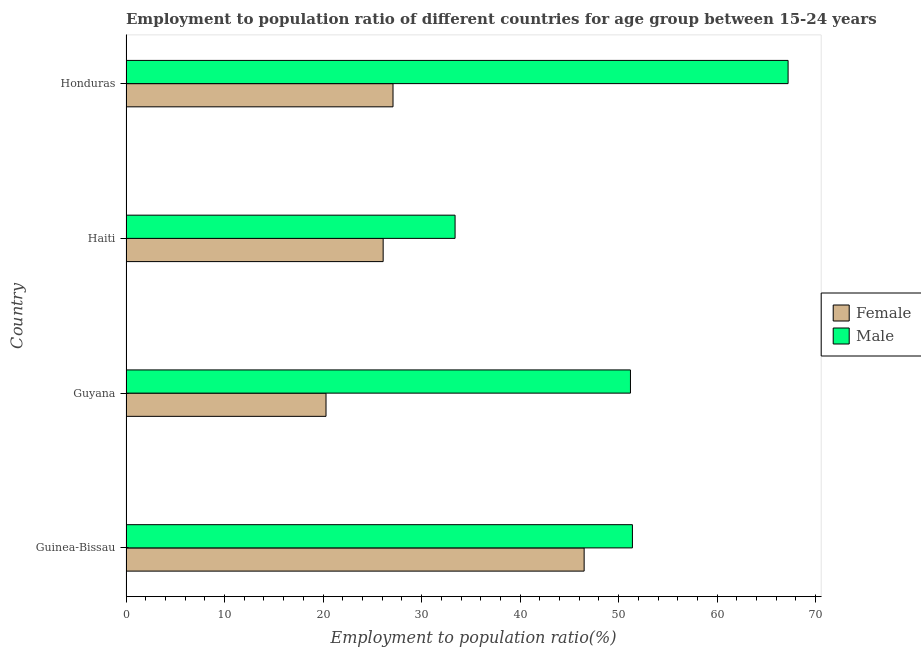Are the number of bars on each tick of the Y-axis equal?
Make the answer very short. Yes. How many bars are there on the 1st tick from the top?
Offer a terse response. 2. What is the label of the 2nd group of bars from the top?
Keep it short and to the point. Haiti. What is the employment to population ratio(female) in Guinea-Bissau?
Your answer should be very brief. 46.5. Across all countries, what is the maximum employment to population ratio(male)?
Provide a succinct answer. 67.2. Across all countries, what is the minimum employment to population ratio(female)?
Ensure brevity in your answer.  20.3. In which country was the employment to population ratio(female) maximum?
Provide a succinct answer. Guinea-Bissau. In which country was the employment to population ratio(female) minimum?
Offer a very short reply. Guyana. What is the total employment to population ratio(female) in the graph?
Offer a very short reply. 120. What is the difference between the employment to population ratio(female) in Guinea-Bissau and that in Honduras?
Provide a succinct answer. 19.4. What is the difference between the employment to population ratio(female) in Guyana and the employment to population ratio(male) in Guinea-Bissau?
Your response must be concise. -31.1. What is the average employment to population ratio(male) per country?
Provide a succinct answer. 50.8. What is the difference between the employment to population ratio(female) and employment to population ratio(male) in Honduras?
Offer a terse response. -40.1. In how many countries, is the employment to population ratio(female) greater than 6 %?
Keep it short and to the point. 4. What is the ratio of the employment to population ratio(female) in Guyana to that in Haiti?
Your answer should be compact. 0.78. Is the employment to population ratio(male) in Guinea-Bissau less than that in Guyana?
Give a very brief answer. No. Is the difference between the employment to population ratio(male) in Guinea-Bissau and Honduras greater than the difference between the employment to population ratio(female) in Guinea-Bissau and Honduras?
Provide a short and direct response. No. What is the difference between the highest and the second highest employment to population ratio(female)?
Offer a very short reply. 19.4. What is the difference between the highest and the lowest employment to population ratio(female)?
Provide a succinct answer. 26.2. In how many countries, is the employment to population ratio(female) greater than the average employment to population ratio(female) taken over all countries?
Offer a very short reply. 1. Is the sum of the employment to population ratio(female) in Guyana and Haiti greater than the maximum employment to population ratio(male) across all countries?
Your answer should be very brief. No. What does the 2nd bar from the top in Honduras represents?
Offer a terse response. Female. How many bars are there?
Make the answer very short. 8. How many countries are there in the graph?
Offer a terse response. 4. Are the values on the major ticks of X-axis written in scientific E-notation?
Your response must be concise. No. How are the legend labels stacked?
Ensure brevity in your answer.  Vertical. What is the title of the graph?
Make the answer very short. Employment to population ratio of different countries for age group between 15-24 years. Does "Passenger Transport Items" appear as one of the legend labels in the graph?
Keep it short and to the point. No. What is the label or title of the Y-axis?
Keep it short and to the point. Country. What is the Employment to population ratio(%) in Female in Guinea-Bissau?
Keep it short and to the point. 46.5. What is the Employment to population ratio(%) in Male in Guinea-Bissau?
Your answer should be very brief. 51.4. What is the Employment to population ratio(%) of Female in Guyana?
Keep it short and to the point. 20.3. What is the Employment to population ratio(%) of Male in Guyana?
Offer a terse response. 51.2. What is the Employment to population ratio(%) of Female in Haiti?
Your answer should be compact. 26.1. What is the Employment to population ratio(%) of Male in Haiti?
Offer a terse response. 33.4. What is the Employment to population ratio(%) of Female in Honduras?
Keep it short and to the point. 27.1. What is the Employment to population ratio(%) of Male in Honduras?
Ensure brevity in your answer.  67.2. Across all countries, what is the maximum Employment to population ratio(%) of Female?
Offer a very short reply. 46.5. Across all countries, what is the maximum Employment to population ratio(%) of Male?
Your response must be concise. 67.2. Across all countries, what is the minimum Employment to population ratio(%) in Female?
Keep it short and to the point. 20.3. Across all countries, what is the minimum Employment to population ratio(%) of Male?
Give a very brief answer. 33.4. What is the total Employment to population ratio(%) of Female in the graph?
Make the answer very short. 120. What is the total Employment to population ratio(%) in Male in the graph?
Keep it short and to the point. 203.2. What is the difference between the Employment to population ratio(%) in Female in Guinea-Bissau and that in Guyana?
Provide a short and direct response. 26.2. What is the difference between the Employment to population ratio(%) in Female in Guinea-Bissau and that in Haiti?
Provide a short and direct response. 20.4. What is the difference between the Employment to population ratio(%) of Female in Guinea-Bissau and that in Honduras?
Provide a succinct answer. 19.4. What is the difference between the Employment to population ratio(%) in Male in Guinea-Bissau and that in Honduras?
Your answer should be compact. -15.8. What is the difference between the Employment to population ratio(%) of Male in Guyana and that in Haiti?
Provide a succinct answer. 17.8. What is the difference between the Employment to population ratio(%) in Female in Guyana and that in Honduras?
Your response must be concise. -6.8. What is the difference between the Employment to population ratio(%) in Male in Haiti and that in Honduras?
Your response must be concise. -33.8. What is the difference between the Employment to population ratio(%) of Female in Guinea-Bissau and the Employment to population ratio(%) of Male in Haiti?
Keep it short and to the point. 13.1. What is the difference between the Employment to population ratio(%) of Female in Guinea-Bissau and the Employment to population ratio(%) of Male in Honduras?
Provide a succinct answer. -20.7. What is the difference between the Employment to population ratio(%) in Female in Guyana and the Employment to population ratio(%) in Male in Haiti?
Provide a succinct answer. -13.1. What is the difference between the Employment to population ratio(%) in Female in Guyana and the Employment to population ratio(%) in Male in Honduras?
Offer a terse response. -46.9. What is the difference between the Employment to population ratio(%) of Female in Haiti and the Employment to population ratio(%) of Male in Honduras?
Offer a very short reply. -41.1. What is the average Employment to population ratio(%) of Female per country?
Provide a succinct answer. 30. What is the average Employment to population ratio(%) in Male per country?
Ensure brevity in your answer.  50.8. What is the difference between the Employment to population ratio(%) in Female and Employment to population ratio(%) in Male in Guinea-Bissau?
Ensure brevity in your answer.  -4.9. What is the difference between the Employment to population ratio(%) in Female and Employment to population ratio(%) in Male in Guyana?
Provide a succinct answer. -30.9. What is the difference between the Employment to population ratio(%) of Female and Employment to population ratio(%) of Male in Honduras?
Offer a very short reply. -40.1. What is the ratio of the Employment to population ratio(%) of Female in Guinea-Bissau to that in Guyana?
Provide a short and direct response. 2.29. What is the ratio of the Employment to population ratio(%) in Male in Guinea-Bissau to that in Guyana?
Keep it short and to the point. 1. What is the ratio of the Employment to population ratio(%) in Female in Guinea-Bissau to that in Haiti?
Make the answer very short. 1.78. What is the ratio of the Employment to population ratio(%) of Male in Guinea-Bissau to that in Haiti?
Offer a terse response. 1.54. What is the ratio of the Employment to population ratio(%) in Female in Guinea-Bissau to that in Honduras?
Your response must be concise. 1.72. What is the ratio of the Employment to population ratio(%) of Male in Guinea-Bissau to that in Honduras?
Your answer should be compact. 0.76. What is the ratio of the Employment to population ratio(%) in Male in Guyana to that in Haiti?
Your answer should be compact. 1.53. What is the ratio of the Employment to population ratio(%) in Female in Guyana to that in Honduras?
Offer a very short reply. 0.75. What is the ratio of the Employment to population ratio(%) in Male in Guyana to that in Honduras?
Offer a terse response. 0.76. What is the ratio of the Employment to population ratio(%) of Female in Haiti to that in Honduras?
Ensure brevity in your answer.  0.96. What is the ratio of the Employment to population ratio(%) in Male in Haiti to that in Honduras?
Your answer should be very brief. 0.5. What is the difference between the highest and the second highest Employment to population ratio(%) of Female?
Provide a succinct answer. 19.4. What is the difference between the highest and the lowest Employment to population ratio(%) in Female?
Keep it short and to the point. 26.2. What is the difference between the highest and the lowest Employment to population ratio(%) in Male?
Your answer should be very brief. 33.8. 